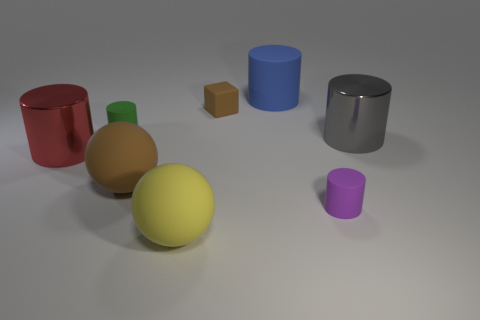Add 2 small cyan rubber cubes. How many objects exist? 10 Subtract all big cylinders. How many cylinders are left? 2 Subtract all green cylinders. Subtract all cyan balls. How many cylinders are left? 4 Subtract all red cylinders. How many yellow balls are left? 1 Subtract all tiny things. Subtract all small yellow shiny blocks. How many objects are left? 5 Add 3 big red things. How many big red things are left? 4 Add 7 brown matte blocks. How many brown matte blocks exist? 8 Subtract all blue cylinders. How many cylinders are left? 4 Subtract 0 blue balls. How many objects are left? 8 Subtract all spheres. How many objects are left? 6 